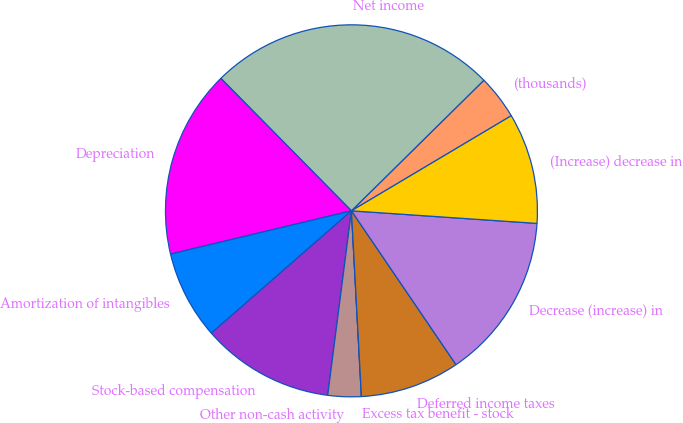Convert chart to OTSL. <chart><loc_0><loc_0><loc_500><loc_500><pie_chart><fcel>(thousands)<fcel>Net income<fcel>Depreciation<fcel>Amortization of intangibles<fcel>Stock-based compensation<fcel>Other non-cash activity<fcel>Excess tax benefit - stock<fcel>Deferred income taxes<fcel>Decrease (increase) in<fcel>(Increase) decrease in<nl><fcel>3.85%<fcel>25.0%<fcel>16.35%<fcel>7.69%<fcel>11.54%<fcel>2.89%<fcel>0.0%<fcel>8.65%<fcel>14.42%<fcel>9.62%<nl></chart> 